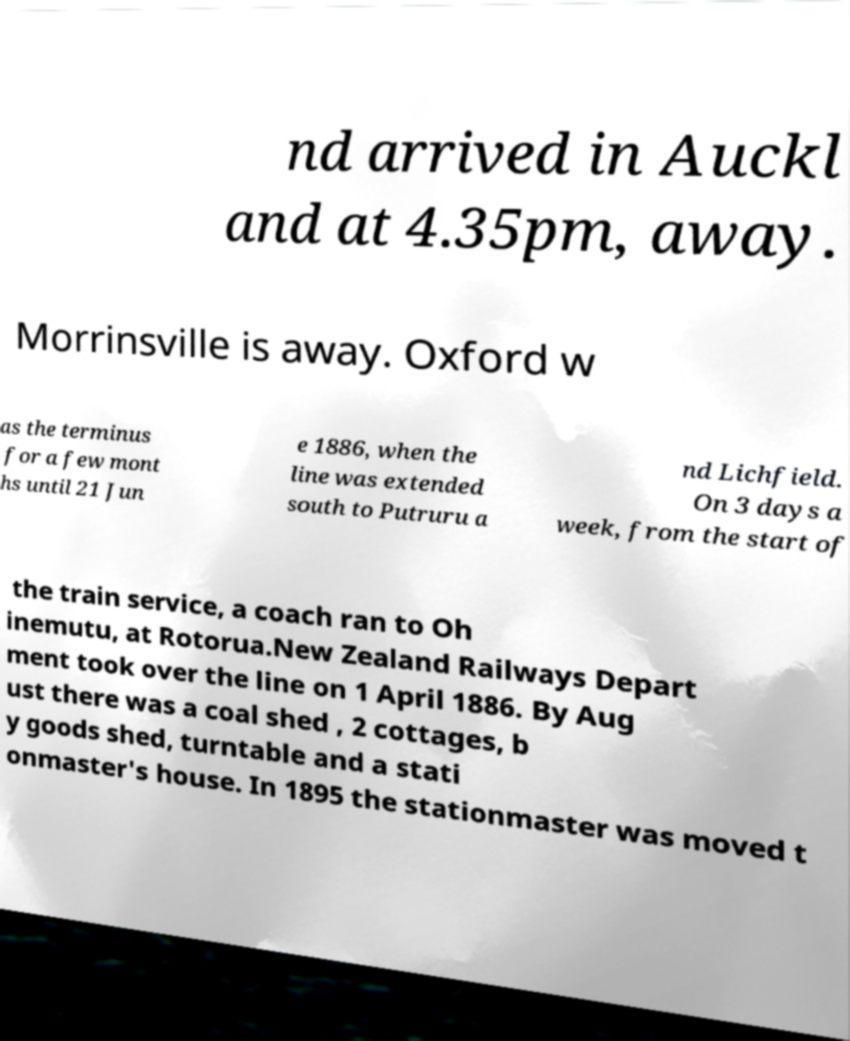I need the written content from this picture converted into text. Can you do that? nd arrived in Auckl and at 4.35pm, away. Morrinsville is away. Oxford w as the terminus for a few mont hs until 21 Jun e 1886, when the line was extended south to Putruru a nd Lichfield. On 3 days a week, from the start of the train service, a coach ran to Oh inemutu, at Rotorua.New Zealand Railways Depart ment took over the line on 1 April 1886. By Aug ust there was a coal shed , 2 cottages, b y goods shed, turntable and a stati onmaster's house. In 1895 the stationmaster was moved t 